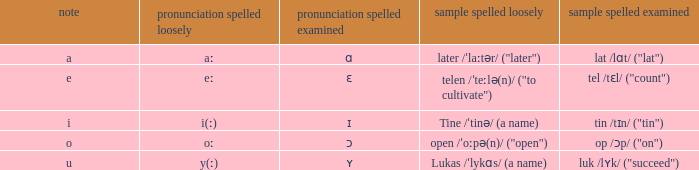What is Pronunciation Spelled Free, when Pronunciation Spelled Checked is "ʏ"? Y(ː). 